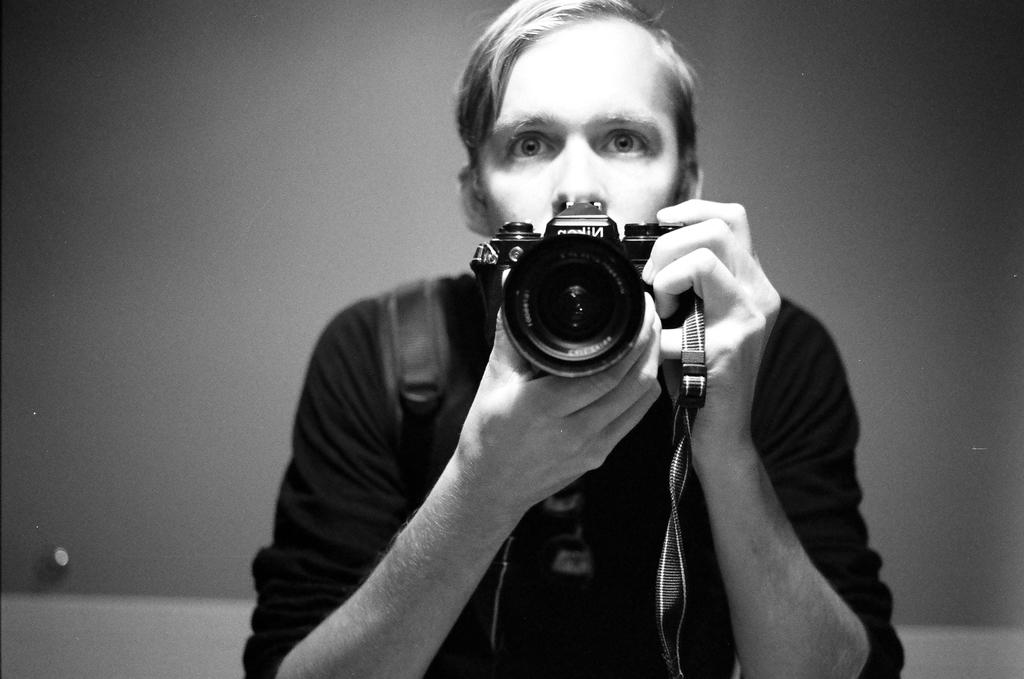What is the main subject of the image? There is a man in the image. What is the man holding in the image? The man is holding a camera. What type of doll is the man using to comb his hair in the image? There is no doll or comb present in the image; the man is holding a camera. 